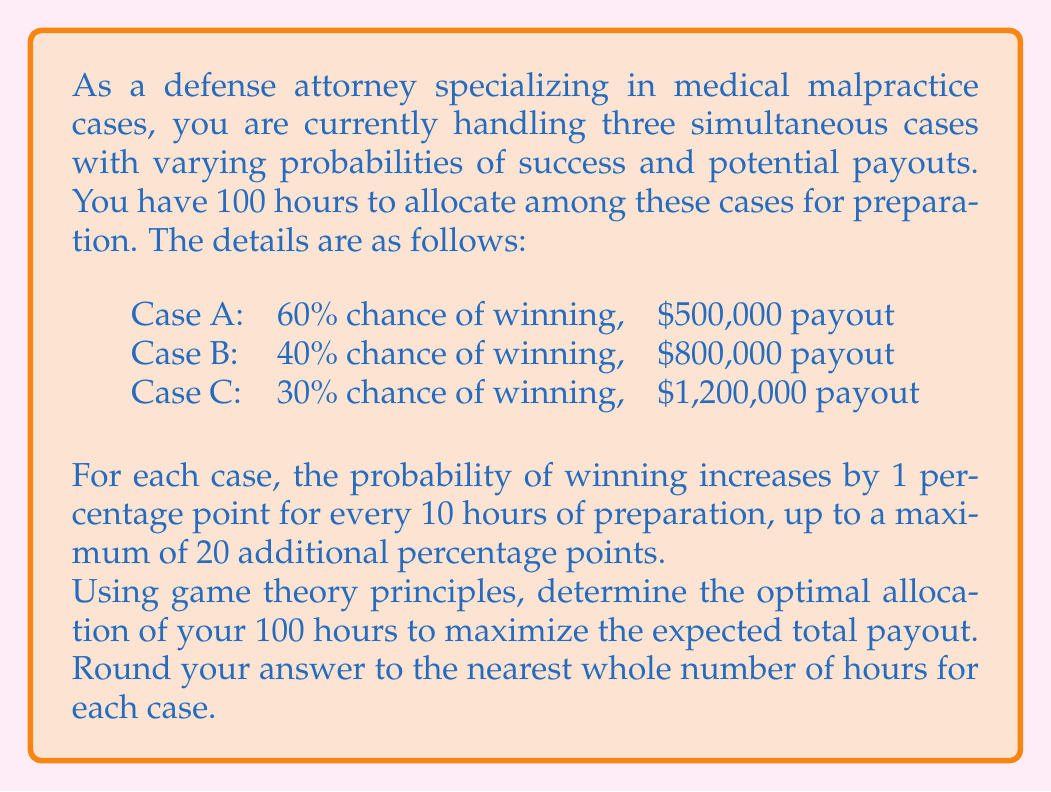Can you answer this question? To solve this problem, we need to use the concept of expected value and marginal benefit analysis from game theory. Let's approach this step-by-step:

1) First, let's define variables:
   $h_A$, $h_B$, $h_C$ = hours allocated to cases A, B, and C respectively

2) The expected value (EV) for each case is:
   $EV_A = (0.60 + 0.01 \cdot \min(h_A/10, 20)) \cdot 500,000$
   $EV_B = (0.40 + 0.01 \cdot \min(h_B/10, 20)) \cdot 800,000$
   $EV_C = (0.30 + 0.01 \cdot \min(h_C/10, 20)) \cdot 1,200,000$

3) Our objective is to maximize:
   $EV_{total} = EV_A + EV_B + EV_C$

4) Subject to the constraint:
   $h_A + h_B + h_C = 100$

5) The marginal benefit (MB) for each hour spent on a case is:
   $MB_A = 5,000$ per hour (up to 200 hours)
   $MB_B = 8,000$ per hour (up to 200 hours)
   $MB_C = 12,000$ per hour (up to 200 hours)

6) The optimal strategy is to allocate hours to the case with the highest marginal benefit until it reaches its maximum benefit, then move to the next highest, and so on.

7) Case C has the highest MB, so we allocate 200 hours to it first. However, we only have 100 hours total, so we allocate all 100 hours to Case C.

8) After allocating 100 hours:
   $EV_A = 0.60 \cdot 500,000 = 300,000$
   $EV_B = 0.40 \cdot 800,000 = 320,000$
   $EV_C = (0.30 + 0.10) \cdot 1,200,000 = 480,000$

9) Total expected value:
   $EV_{total} = 300,000 + 320,000 + 480,000 = 1,100,000$

Therefore, the optimal strategy is to allocate all 100 hours to Case C.
Answer: The optimal allocation of hours is:
Case A: 0 hours
Case B: 0 hours
Case C: 100 hours 